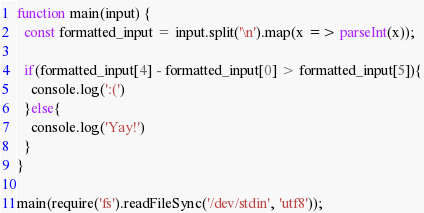Convert code to text. <code><loc_0><loc_0><loc_500><loc_500><_JavaScript_>function main(input) {
  const formatted_input = input.split('\n').map(x => parseInt(x));

  if(formatted_input[4] - formatted_input[0] > formatted_input[5]){
    console.log(':(')
  }else{
    console.log('Yay!')
  }
}

main(require('fs').readFileSync('/dev/stdin', 'utf8'));

</code> 